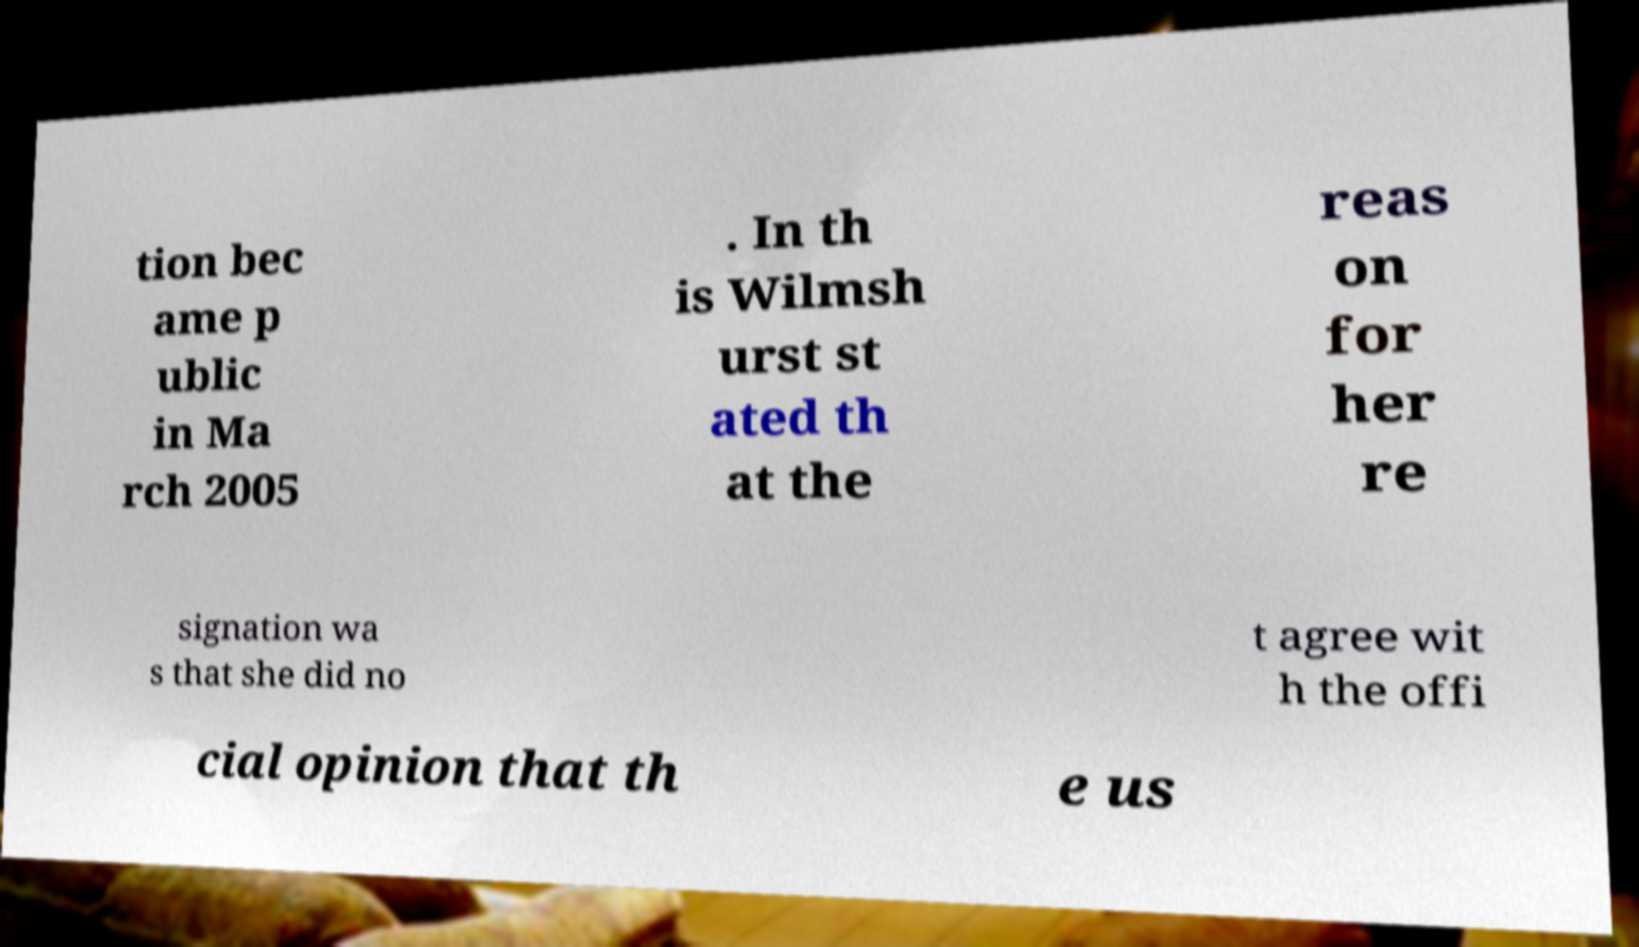For documentation purposes, I need the text within this image transcribed. Could you provide that? tion bec ame p ublic in Ma rch 2005 . In th is Wilmsh urst st ated th at the reas on for her re signation wa s that she did no t agree wit h the offi cial opinion that th e us 